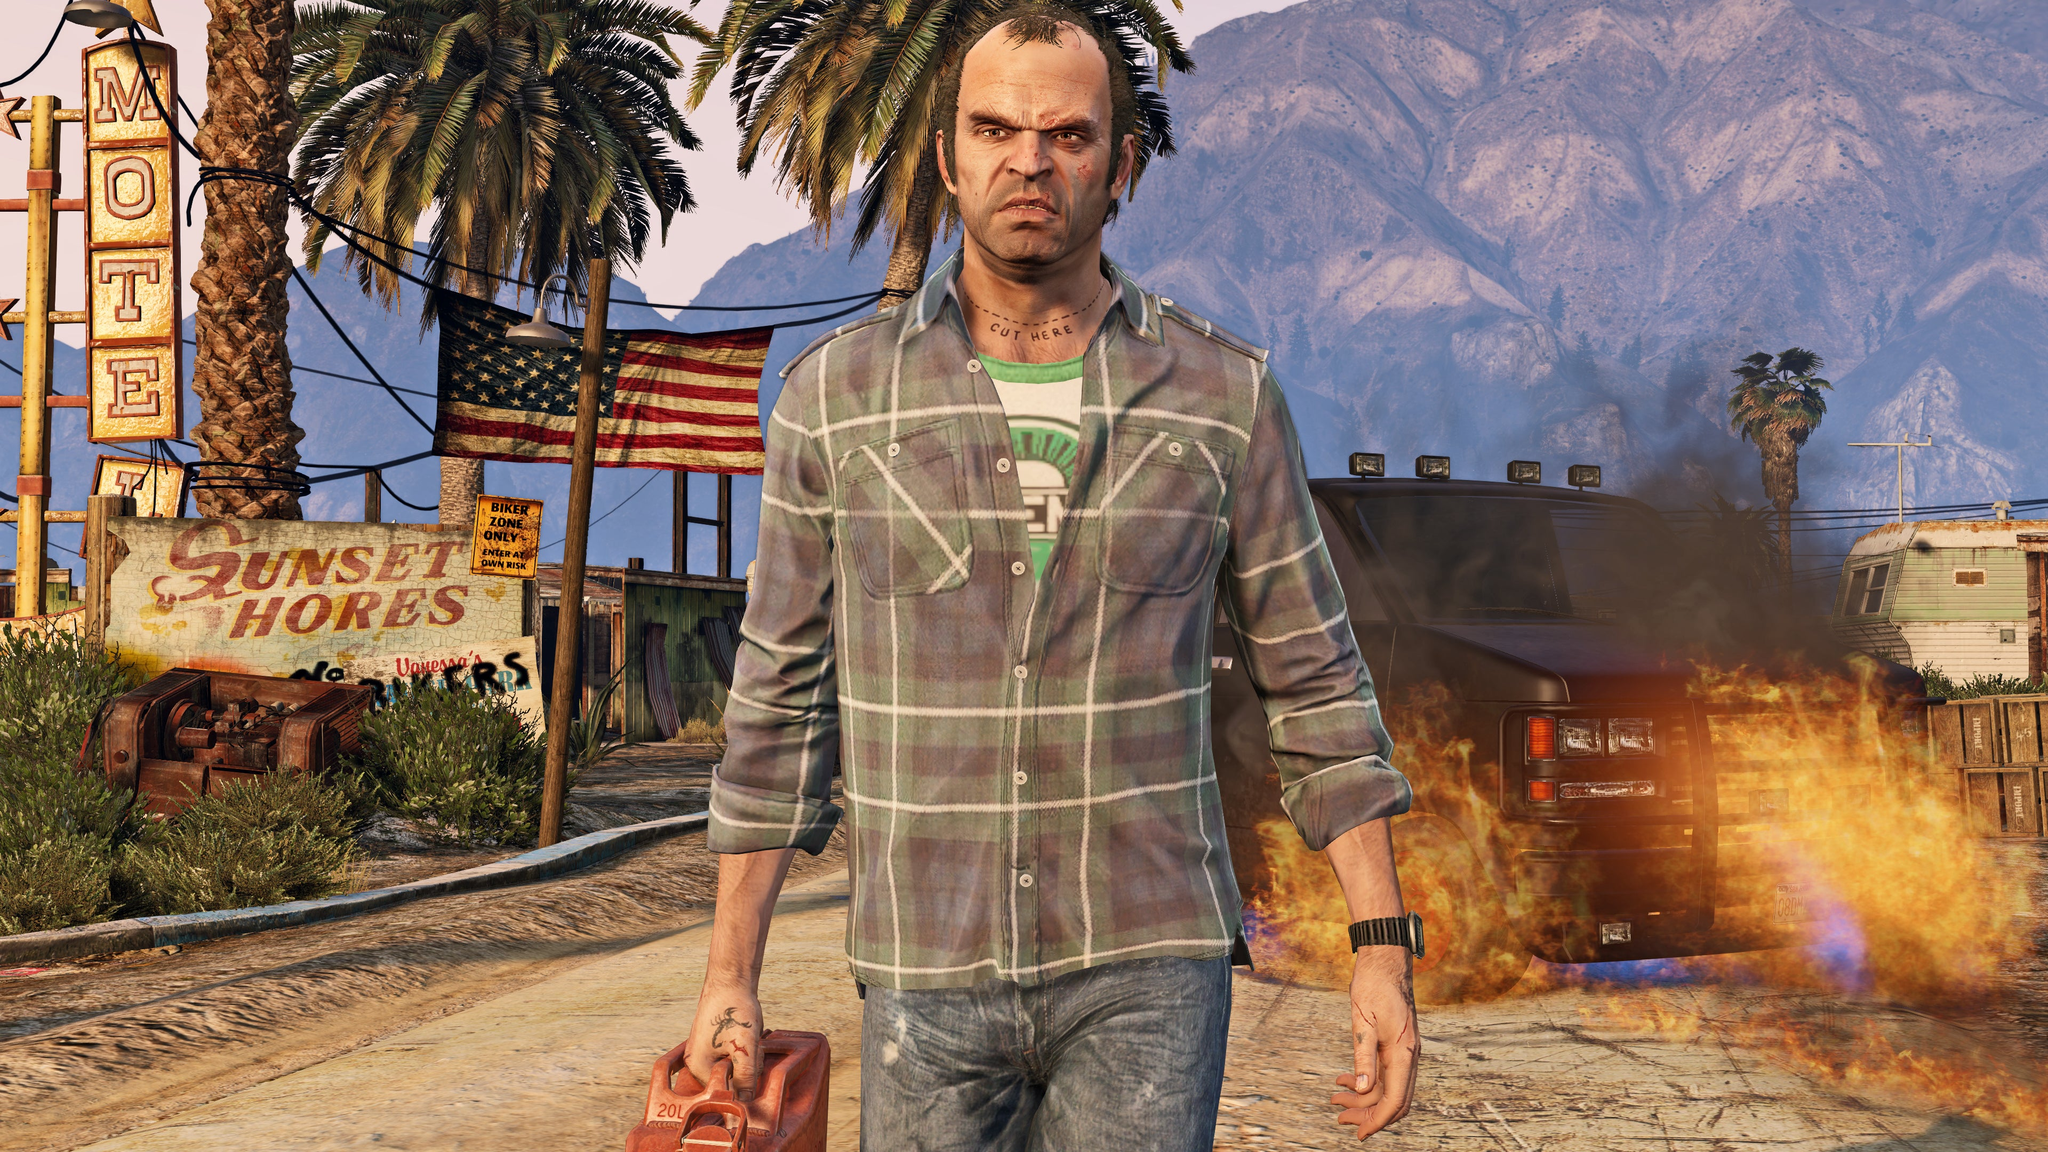Could you describe the potential backstory of the character in the foreground based on the visual cues? The character in the foreground, carrying a gas can and looking stern, suggests a possible story of desperation or rebellion. His rugged appearance, marked by the determined expression and casual yet rugged attire, hints at someone who might be involved in rough or criminal activities. The background further supports this narrative, with the rundown motel, graffitied signs, and unattended fire creating a post-apocalyptic or lawless atmosphere. This character might be part of a larger story of survival or conflict in a region that has faced severe economic and social upheaval. 